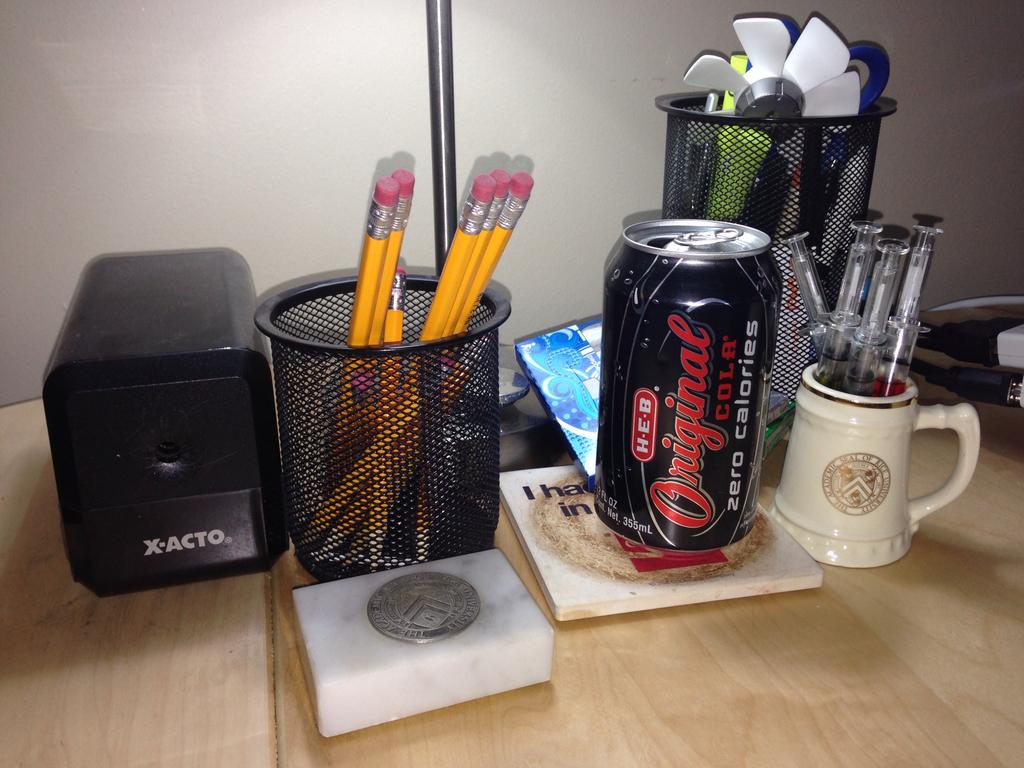What is on the soda can?
Keep it short and to the point. Original cola. 